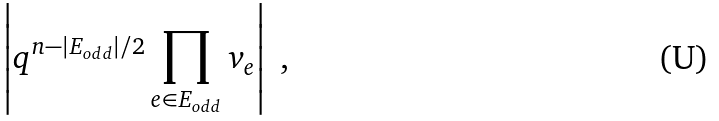Convert formula to latex. <formula><loc_0><loc_0><loc_500><loc_500>\left | q ^ { n - | E _ { o d d } | / 2 } \prod _ { e \in E _ { o d d } } v _ { e } \right | \ ,</formula> 